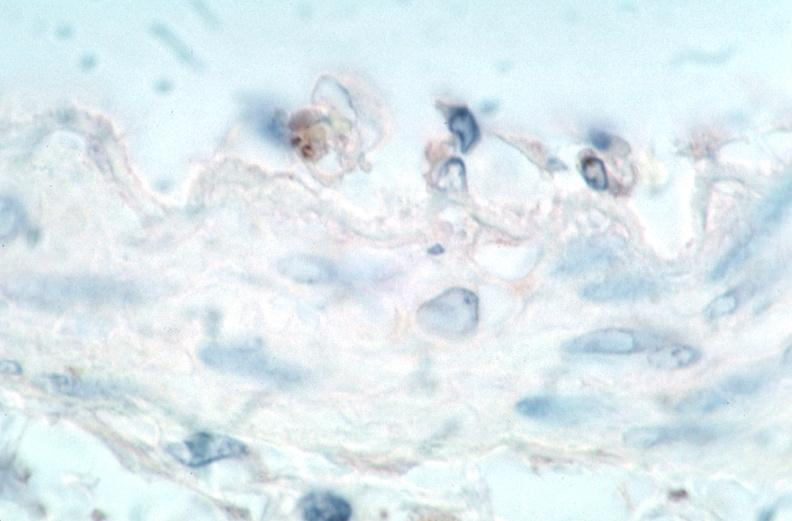s lateral view present?
Answer the question using a single word or phrase. No 